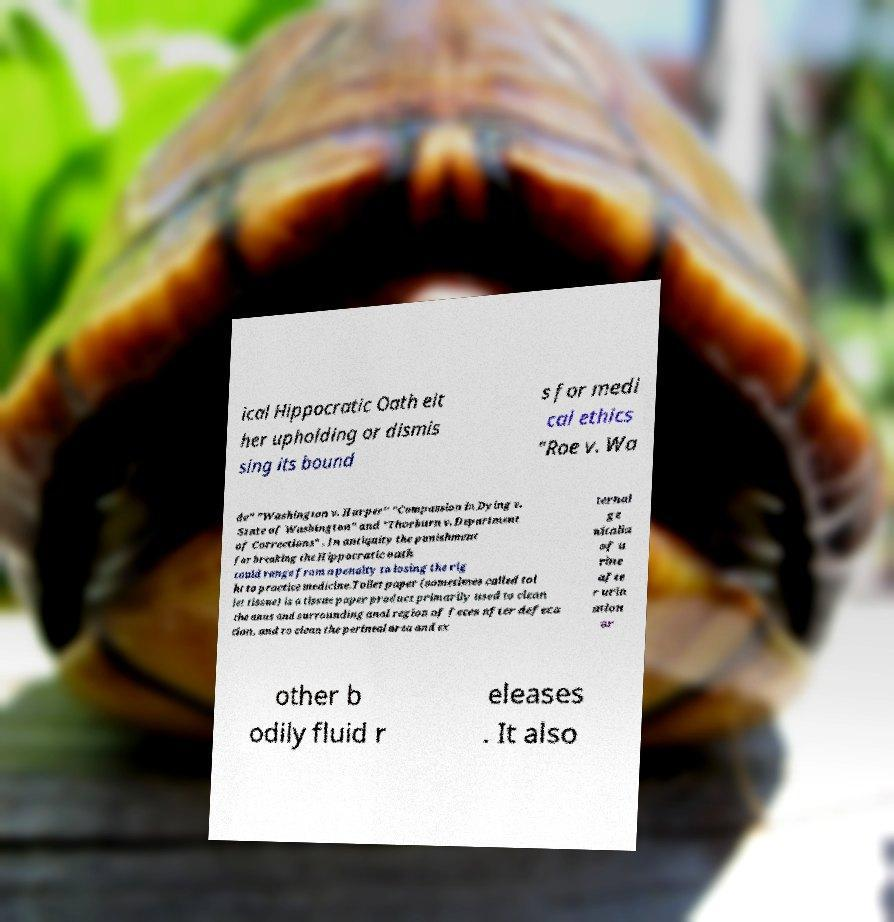Please read and relay the text visible in this image. What does it say? ical Hippocratic Oath eit her upholding or dismis sing its bound s for medi cal ethics "Roe v. Wa de" "Washington v. Harper" "Compassion in Dying v. State of Washington" and "Thorburn v. Department of Corrections" . In antiquity the punishment for breaking the Hippocratic oath could range from a penalty to losing the rig ht to practice medicine.Toilet paper (sometimes called toi let tissue) is a tissue paper product primarily used to clean the anus and surrounding anal region of feces after defeca tion, and to clean the perineal area and ex ternal ge nitalia of u rine afte r urin ation or other b odily fluid r eleases . It also 